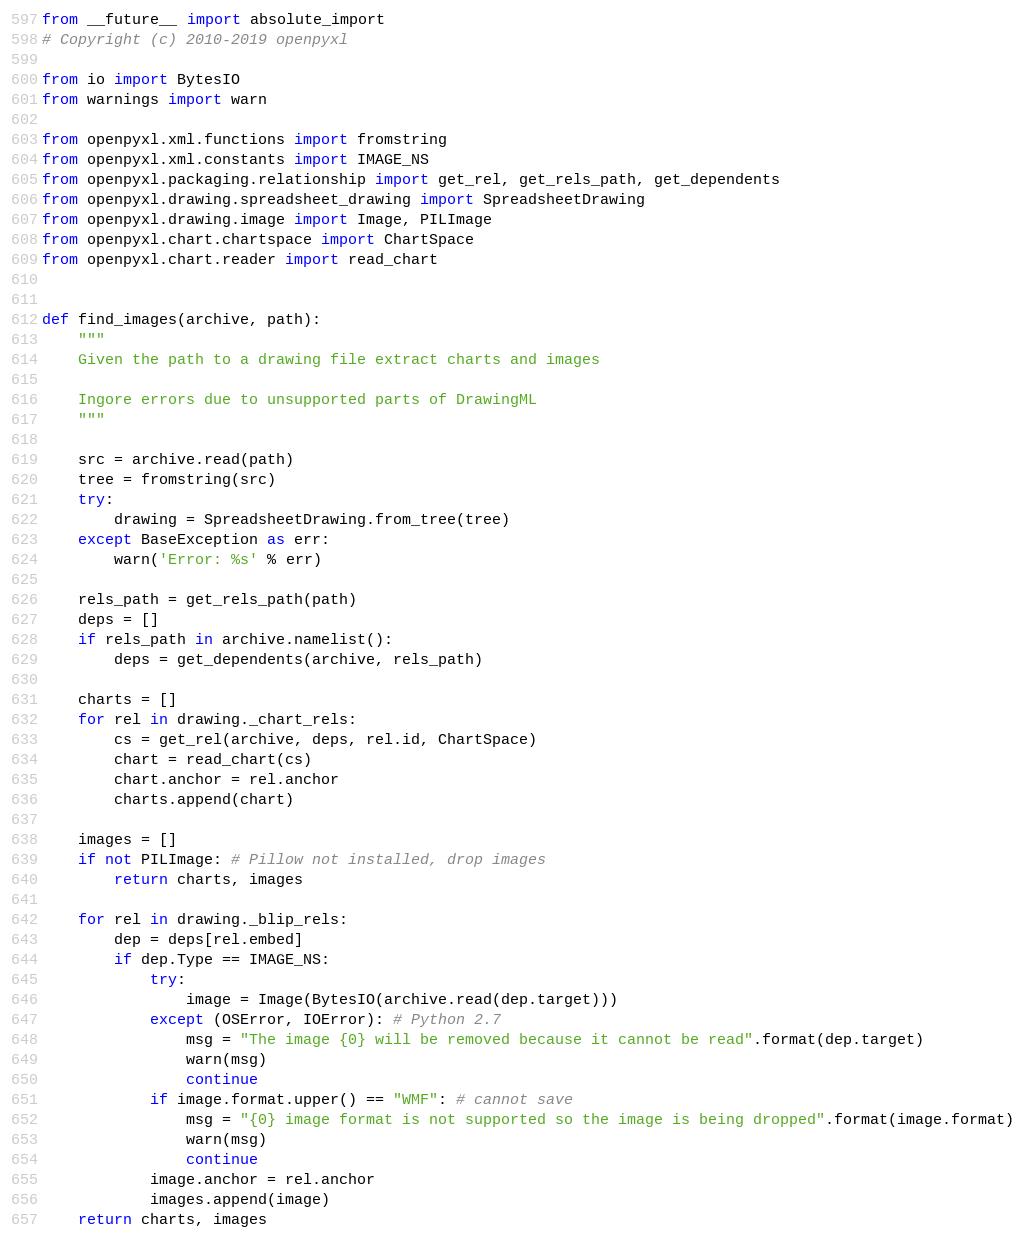<code> <loc_0><loc_0><loc_500><loc_500><_Python_>from __future__ import absolute_import
# Copyright (c) 2010-2019 openpyxl

from io import BytesIO
from warnings import warn

from openpyxl.xml.functions import fromstring
from openpyxl.xml.constants import IMAGE_NS
from openpyxl.packaging.relationship import get_rel, get_rels_path, get_dependents
from openpyxl.drawing.spreadsheet_drawing import SpreadsheetDrawing
from openpyxl.drawing.image import Image, PILImage
from openpyxl.chart.chartspace import ChartSpace
from openpyxl.chart.reader import read_chart


def find_images(archive, path):
    """
    Given the path to a drawing file extract charts and images

    Ingore errors due to unsupported parts of DrawingML
    """

    src = archive.read(path)
    tree = fromstring(src)
    try:
        drawing = SpreadsheetDrawing.from_tree(tree)
    except BaseException as err:
        warn('Error: %s' % err)

    rels_path = get_rels_path(path)
    deps = []
    if rels_path in archive.namelist():
        deps = get_dependents(archive, rels_path)

    charts = []
    for rel in drawing._chart_rels:
        cs = get_rel(archive, deps, rel.id, ChartSpace)
        chart = read_chart(cs)
        chart.anchor = rel.anchor
        charts.append(chart)

    images = []
    if not PILImage: # Pillow not installed, drop images
        return charts, images

    for rel in drawing._blip_rels:
        dep = deps[rel.embed]
        if dep.Type == IMAGE_NS:
            try:
                image = Image(BytesIO(archive.read(dep.target)))
            except (OSError, IOError): # Python 2.7
                msg = "The image {0} will be removed because it cannot be read".format(dep.target)
                warn(msg)
                continue
            if image.format.upper() == "WMF": # cannot save
                msg = "{0} image format is not supported so the image is being dropped".format(image.format)
                warn(msg)
                continue
            image.anchor = rel.anchor
            images.append(image)
    return charts, images
</code> 